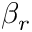<formula> <loc_0><loc_0><loc_500><loc_500>\beta _ { r }</formula> 